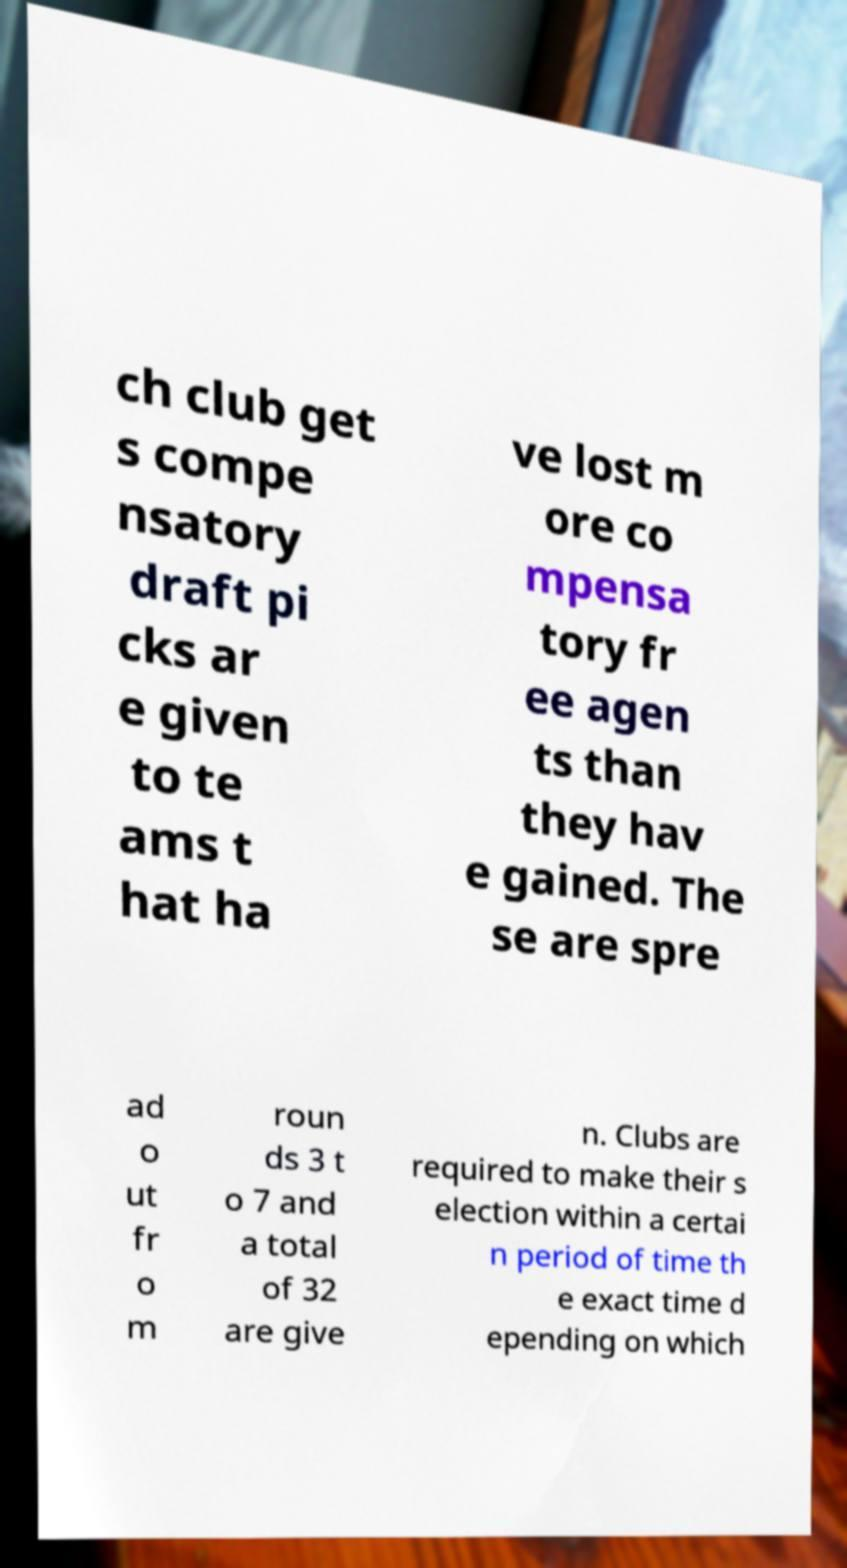For documentation purposes, I need the text within this image transcribed. Could you provide that? ch club get s compe nsatory draft pi cks ar e given to te ams t hat ha ve lost m ore co mpensa tory fr ee agen ts than they hav e gained. The se are spre ad o ut fr o m roun ds 3 t o 7 and a total of 32 are give n. Clubs are required to make their s election within a certai n period of time th e exact time d epending on which 